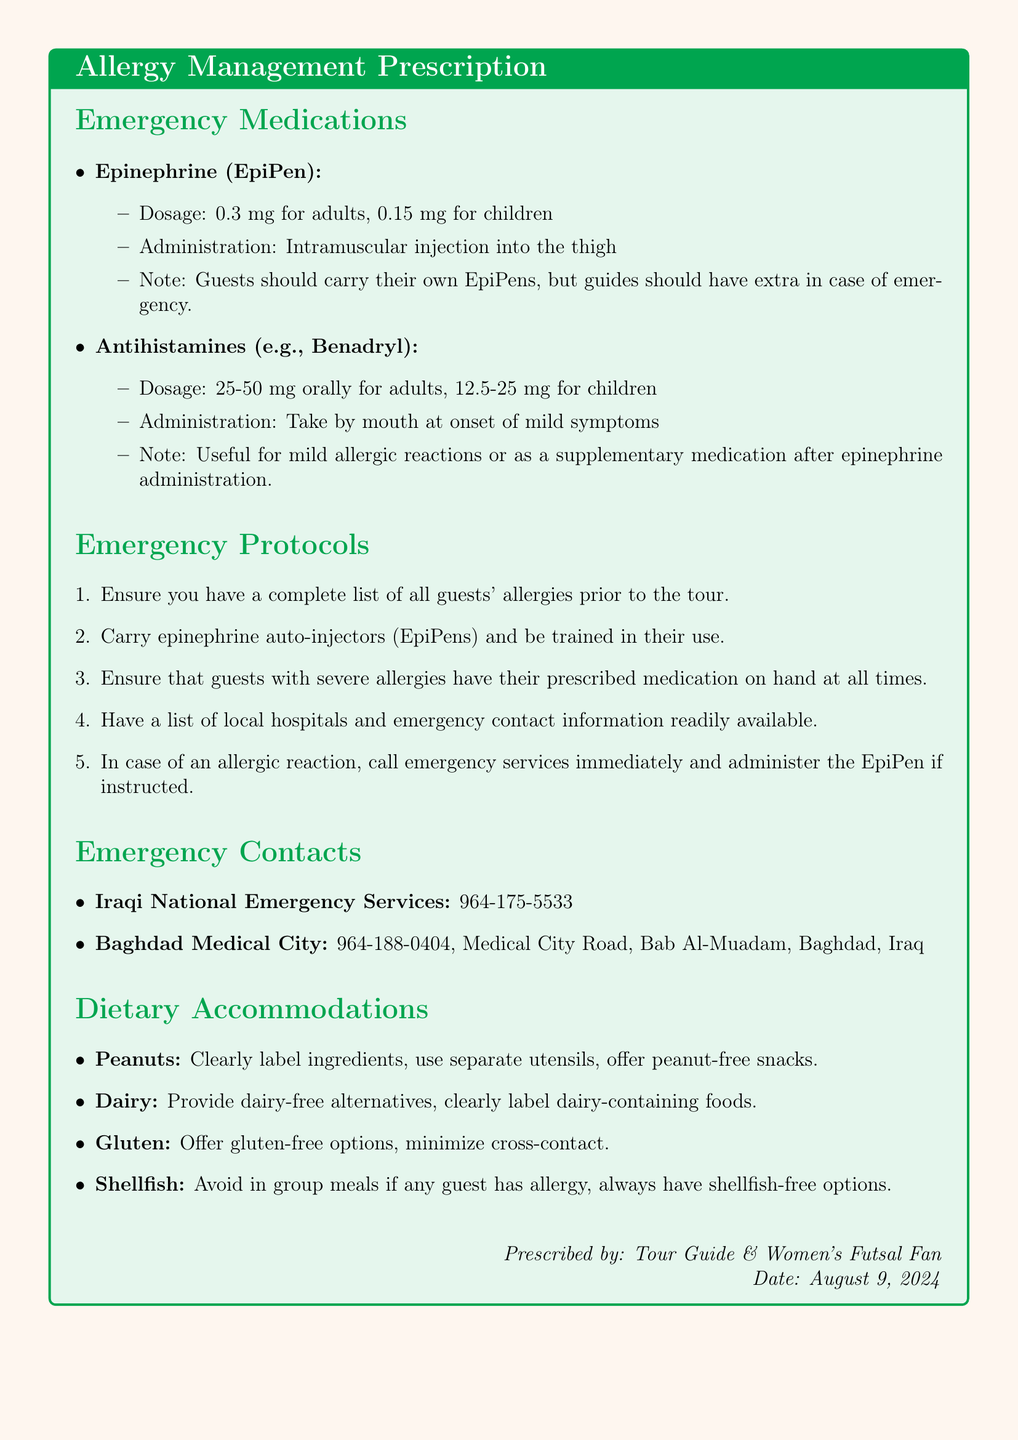What is the dosage of epinephrine for adults? The dosage of epinephrine for adults is specified in the document under emergency medications.
Answer: 0.3 mg What should guests carry for severe allergies? The document mentions what guests should have on hand in case of severe allergies.
Answer: EpiPens What is the contact number for Iraqi National Emergency Services? The document lists the contact numbers for emergency services.
Answer: 964-175-5533 Which antihistamine is mentioned as an emergency medication? The document lists medications under emergency medications, mentioning one by name.
Answer: Benadryl What alternative should be provided for dairy allergies? The document specifies accommodations for dietary needs, focusing on dairy.
Answer: Dairy-free alternatives In case of an allergic reaction, what should be done first according to the emergency protocols? The document outlines initial steps during allergic reactions under emergency protocols.
Answer: Call emergency services What should be done to minimize cross-contact with gluten? The document suggests how to handle gluten for guests with allergies.
Answer: Minimize cross-contact Which medical facility's number is listed in the document? The document contains contact information for a medical facility.
Answer: Baghdad Medical City What should be offered for guests with peanut allergies? The document specifies dietary accommodations regarding peanuts.
Answer: Peanut-free snacks 